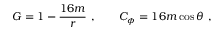Convert formula to latex. <formula><loc_0><loc_0><loc_500><loc_500>G = 1 - { \frac { 1 6 m } { r } } \ , \quad C _ { \phi } = 1 6 m \cos \theta \ ,</formula> 